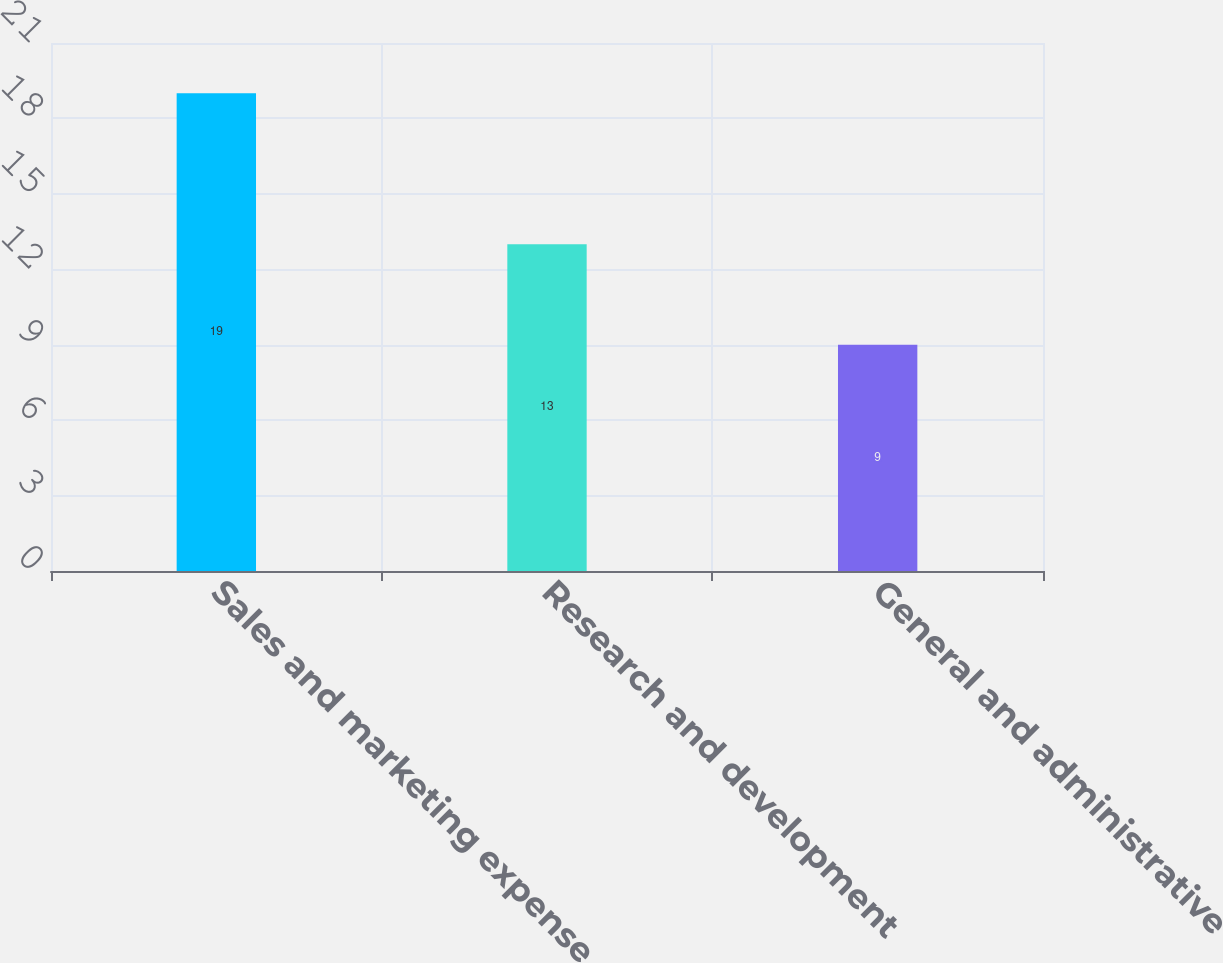<chart> <loc_0><loc_0><loc_500><loc_500><bar_chart><fcel>Sales and marketing expense<fcel>Research and development<fcel>General and administrative<nl><fcel>19<fcel>13<fcel>9<nl></chart> 